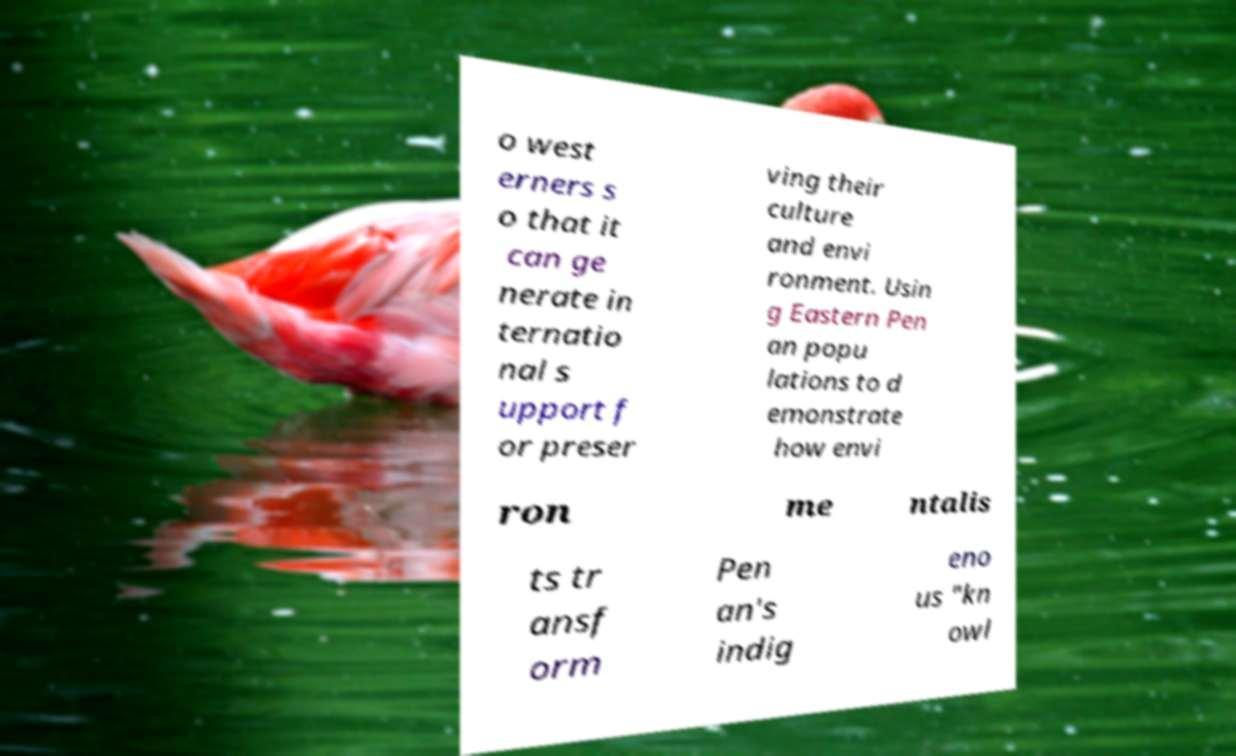Could you assist in decoding the text presented in this image and type it out clearly? o west erners s o that it can ge nerate in ternatio nal s upport f or preser ving their culture and envi ronment. Usin g Eastern Pen an popu lations to d emonstrate how envi ron me ntalis ts tr ansf orm Pen an's indig eno us "kn owl 